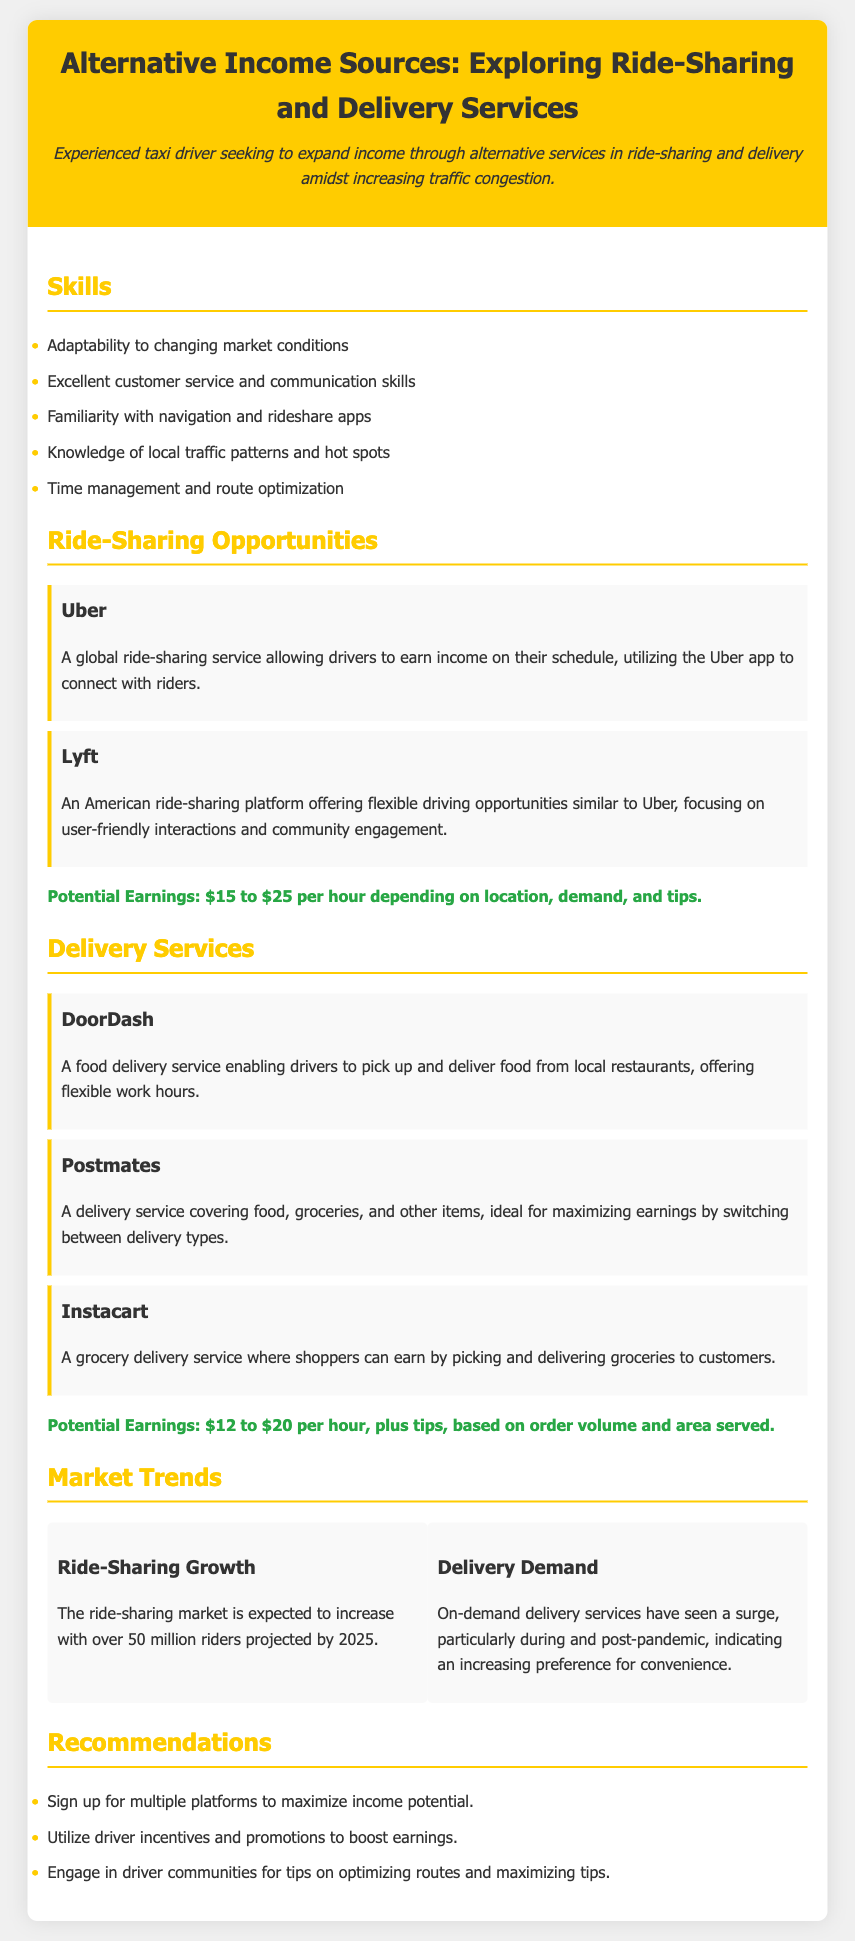what are the ride-sharing opportunities mentioned? The document lists specific platforms for ride-sharing opportunities, including Uber and Lyft.
Answer: Uber, Lyft what is the potential earnings for ride-sharing services? The document specifies the range of potential earnings for ride-sharing services based on location, demand, and tips.
Answer: $15 to $25 per hour what delivery services are mentioned in the document? The document details several delivery services that offer alternative income, including DoorDash, Postmates, and Instacart.
Answer: DoorDash, Postmates, Instacart what is the expected growth in the ride-sharing market by 2025? The document provides a projection regarding the number of riders in the ride-sharing market by 2025.
Answer: 50 million riders what is a recommendation provided in the document? The document lists several recommendations to maximize income potential while working in alternative services.
Answer: Sign up for multiple platforms to maximize income potential 